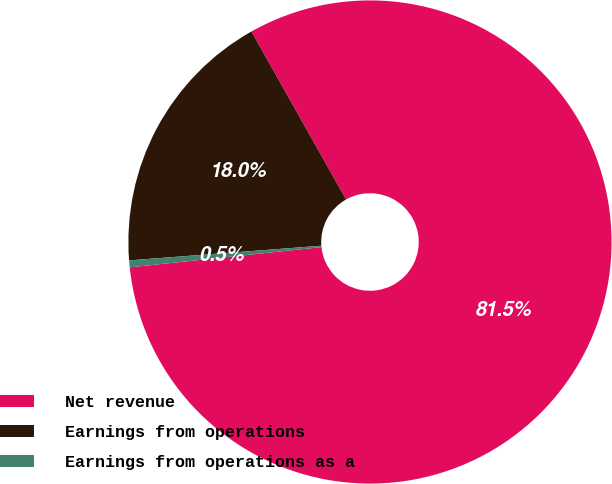Convert chart. <chart><loc_0><loc_0><loc_500><loc_500><pie_chart><fcel>Net revenue<fcel>Earnings from operations<fcel>Earnings from operations as a<nl><fcel>81.49%<fcel>18.05%<fcel>0.46%<nl></chart> 